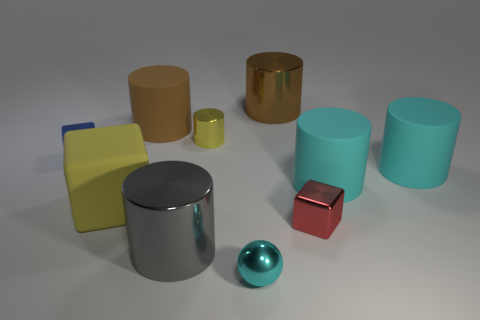Subtract 3 cylinders. How many cylinders are left? 3 Subtract all yellow cylinders. How many cylinders are left? 5 Subtract all tiny cylinders. How many cylinders are left? 5 Subtract all gray cylinders. Subtract all red blocks. How many cylinders are left? 5 Subtract all cylinders. How many objects are left? 4 Subtract 1 cyan cylinders. How many objects are left? 9 Subtract all yellow rubber objects. Subtract all tiny things. How many objects are left? 5 Add 1 big brown cylinders. How many big brown cylinders are left? 3 Add 1 purple balls. How many purple balls exist? 1 